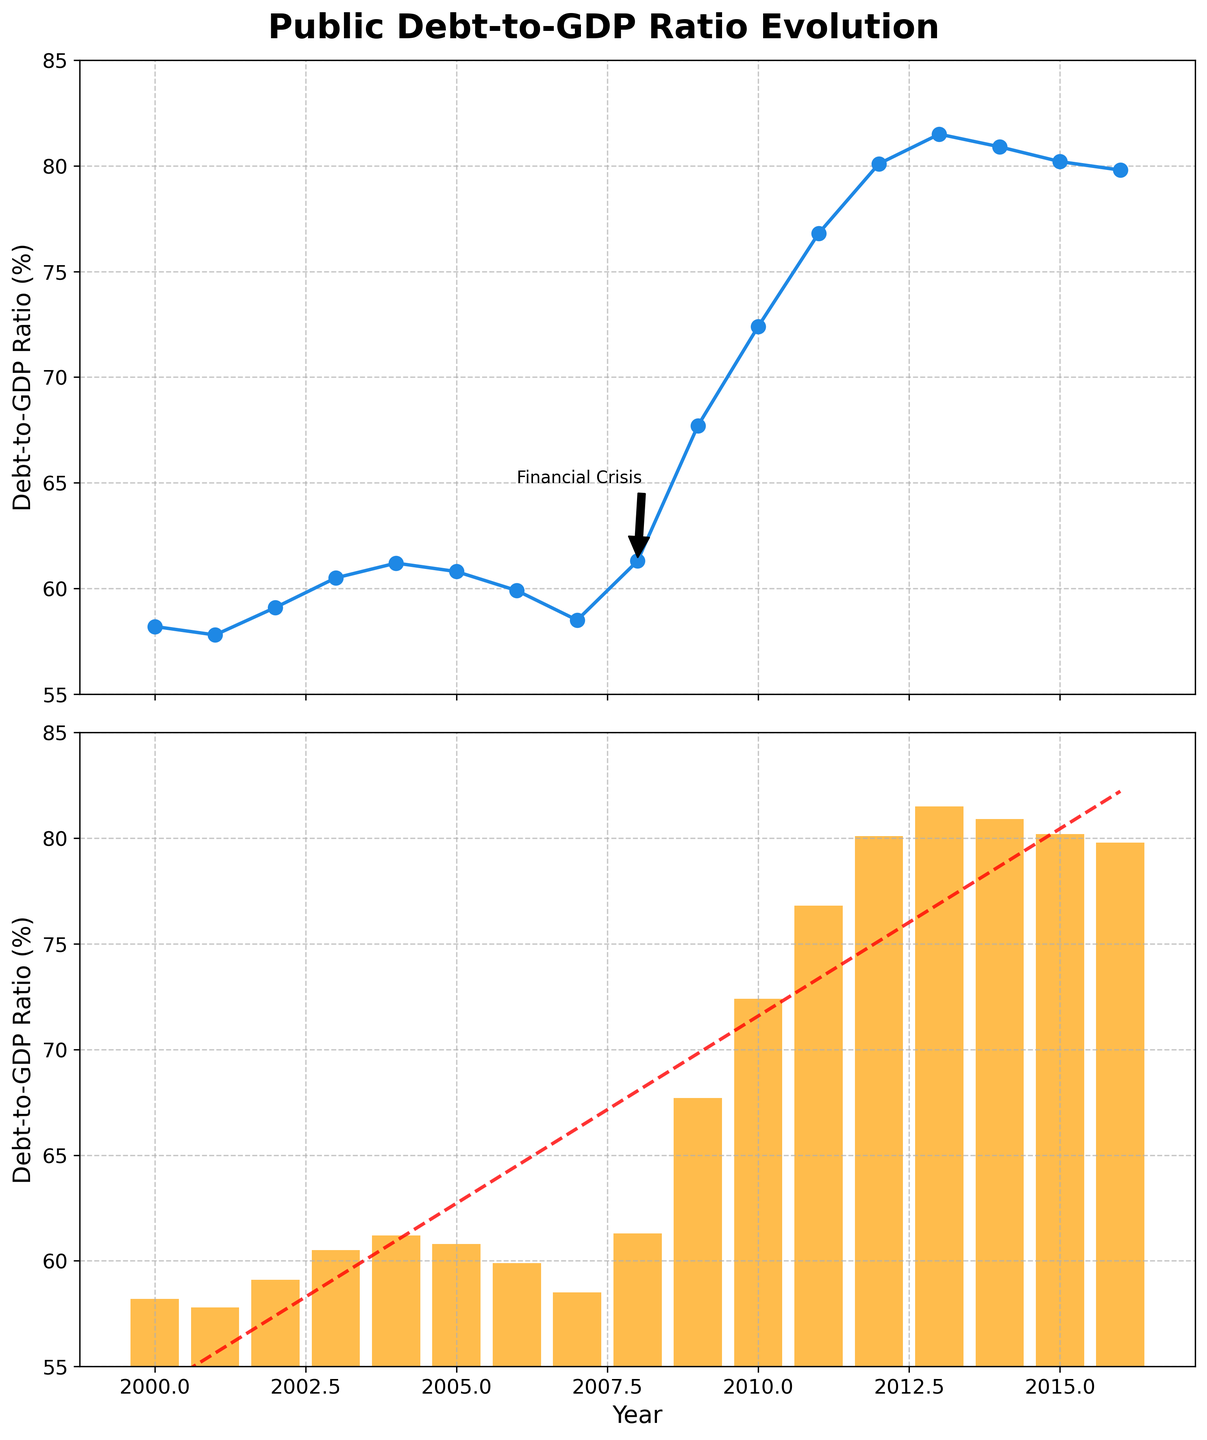What is the general trend of the public debt-to-GDP ratio over the years shown? The trend can be determined by observing the line plot and the trend line in the bar plot. Starting at around 58.2% in 2000, the ratio shows a slight decrease until 2007, followed by a sharp increase reaching its peak around 2013, and then a slight decrease until 2016.
Answer: Generally increasing When did the public debt-to-GDP ratio reach its peak? Upon observing the plots, the highest point on the line plot occurs in 2013, which is around 81.5%.
Answer: 2013 Which year marked a significant increase in the public debt-to-GDP ratio and is annotated in the plot? The annotation "Financial Crisis" related to the year 2008 indicates a significant increase.
Answer: 2008 How much did the public debt-to-GDP ratio increase from 2007 to 2009? In 2007, the ratio was 58.5%, and in 2009, it was 67.7%. The increase can be calculated as 67.7% - 58.5% = 9.2%.
Answer: 9.2% What is the average public debt-to-GDP ratio over the period from 2000 to 2016? Add the ratios for all the years and divide by the number of years. (58.2 + 57.8 + 59.1 + 60.5 + 61.2 + 60.8 + 59.9 + 58.5 + 61.3 + 67.7 + 72.4 + 76.8 + 80.1 + 81.5 + 80.9 + 80.2 + 79.8) / 17 = 67.88% approximately
Answer: 67.88% In which year did the public debt-to-GDP ratio decline after peaking at 81.5%? Following the peak in 2013, the ratio shows a decline in 2014.
Answer: 2014 During which years did the public debt-to-GDP ratio stay below 60%? Observing the plots, the ratio stayed below 60% from 2000 to 2002, and again from 2005 to 2007.
Answer: 2000-2002, 2005-2007 What is the difference between the highest and lowest public debt-to-GDP ratios observed? The highest ratio is 81.5% in 2013 and the lowest is 57.8% in 2001. The difference can be calculated as 81.5% - 57.8% = 23.7%.
Answer: 23.7% Which subplot visually emphasizes sharp changes more effectively, the line plot or the bar plot? The line plot, with its connected points and annotations, makes sharp changes and trends more visually evident compared to the bar plot.
Answer: Line plot How did the public debt-to-GDP ratio change after the year 2010? After 2010, the ratio continued to increase until around 2013 before starting to decrease slightly towards 2016.
Answer: Increased, then decreased 